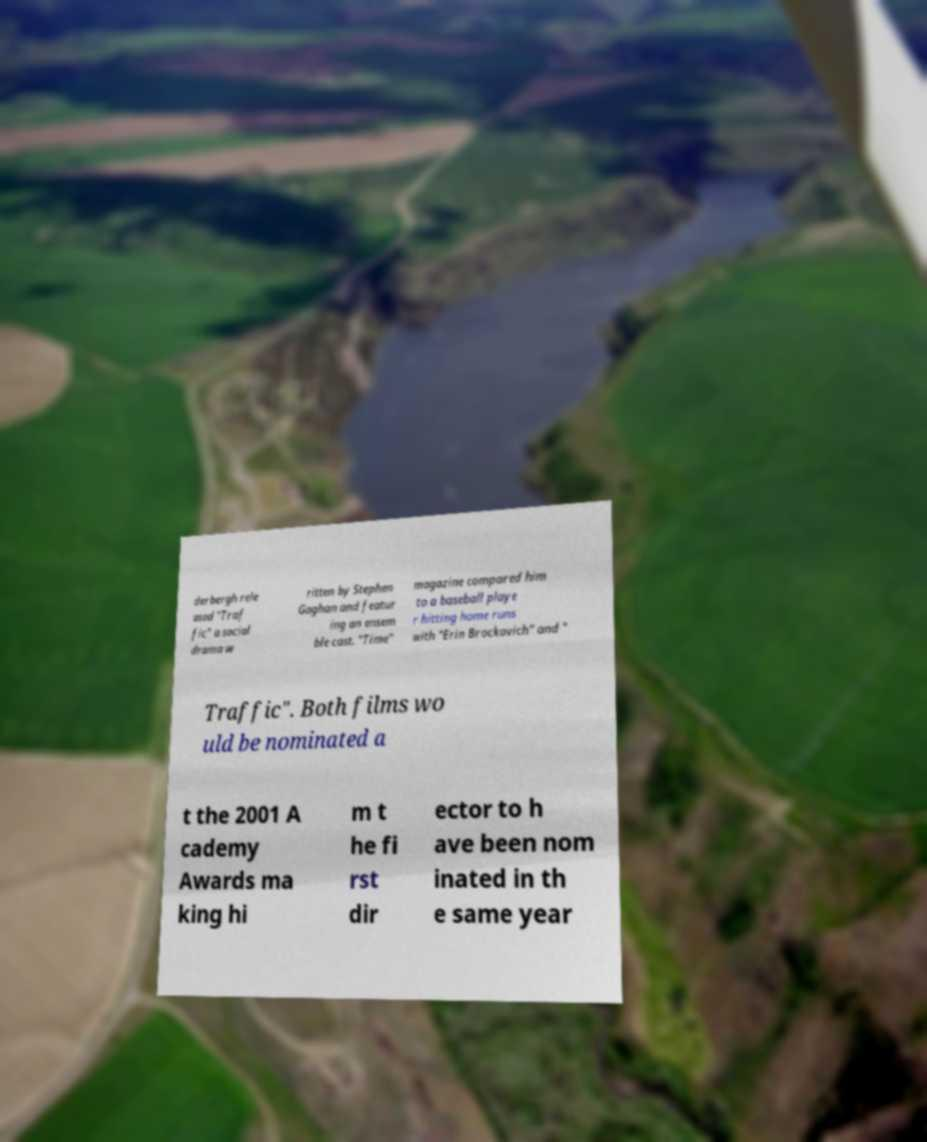There's text embedded in this image that I need extracted. Can you transcribe it verbatim? derbergh rele ased "Traf fic" a social drama w ritten by Stephen Gaghan and featur ing an ensem ble cast. "Time" magazine compared him to a baseball playe r hitting home runs with "Erin Brockovich" and " Traffic". Both films wo uld be nominated a t the 2001 A cademy Awards ma king hi m t he fi rst dir ector to h ave been nom inated in th e same year 